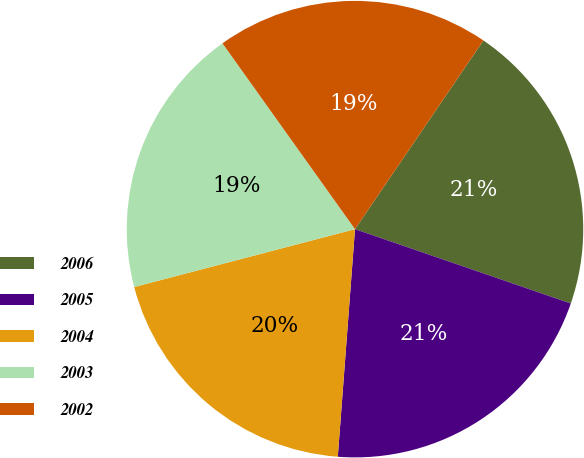Convert chart to OTSL. <chart><loc_0><loc_0><loc_500><loc_500><pie_chart><fcel>2006<fcel>2005<fcel>2004<fcel>2003<fcel>2002<nl><fcel>20.77%<fcel>20.92%<fcel>19.72%<fcel>19.22%<fcel>19.37%<nl></chart> 